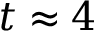Convert formula to latex. <formula><loc_0><loc_0><loc_500><loc_500>t \approx 4</formula> 